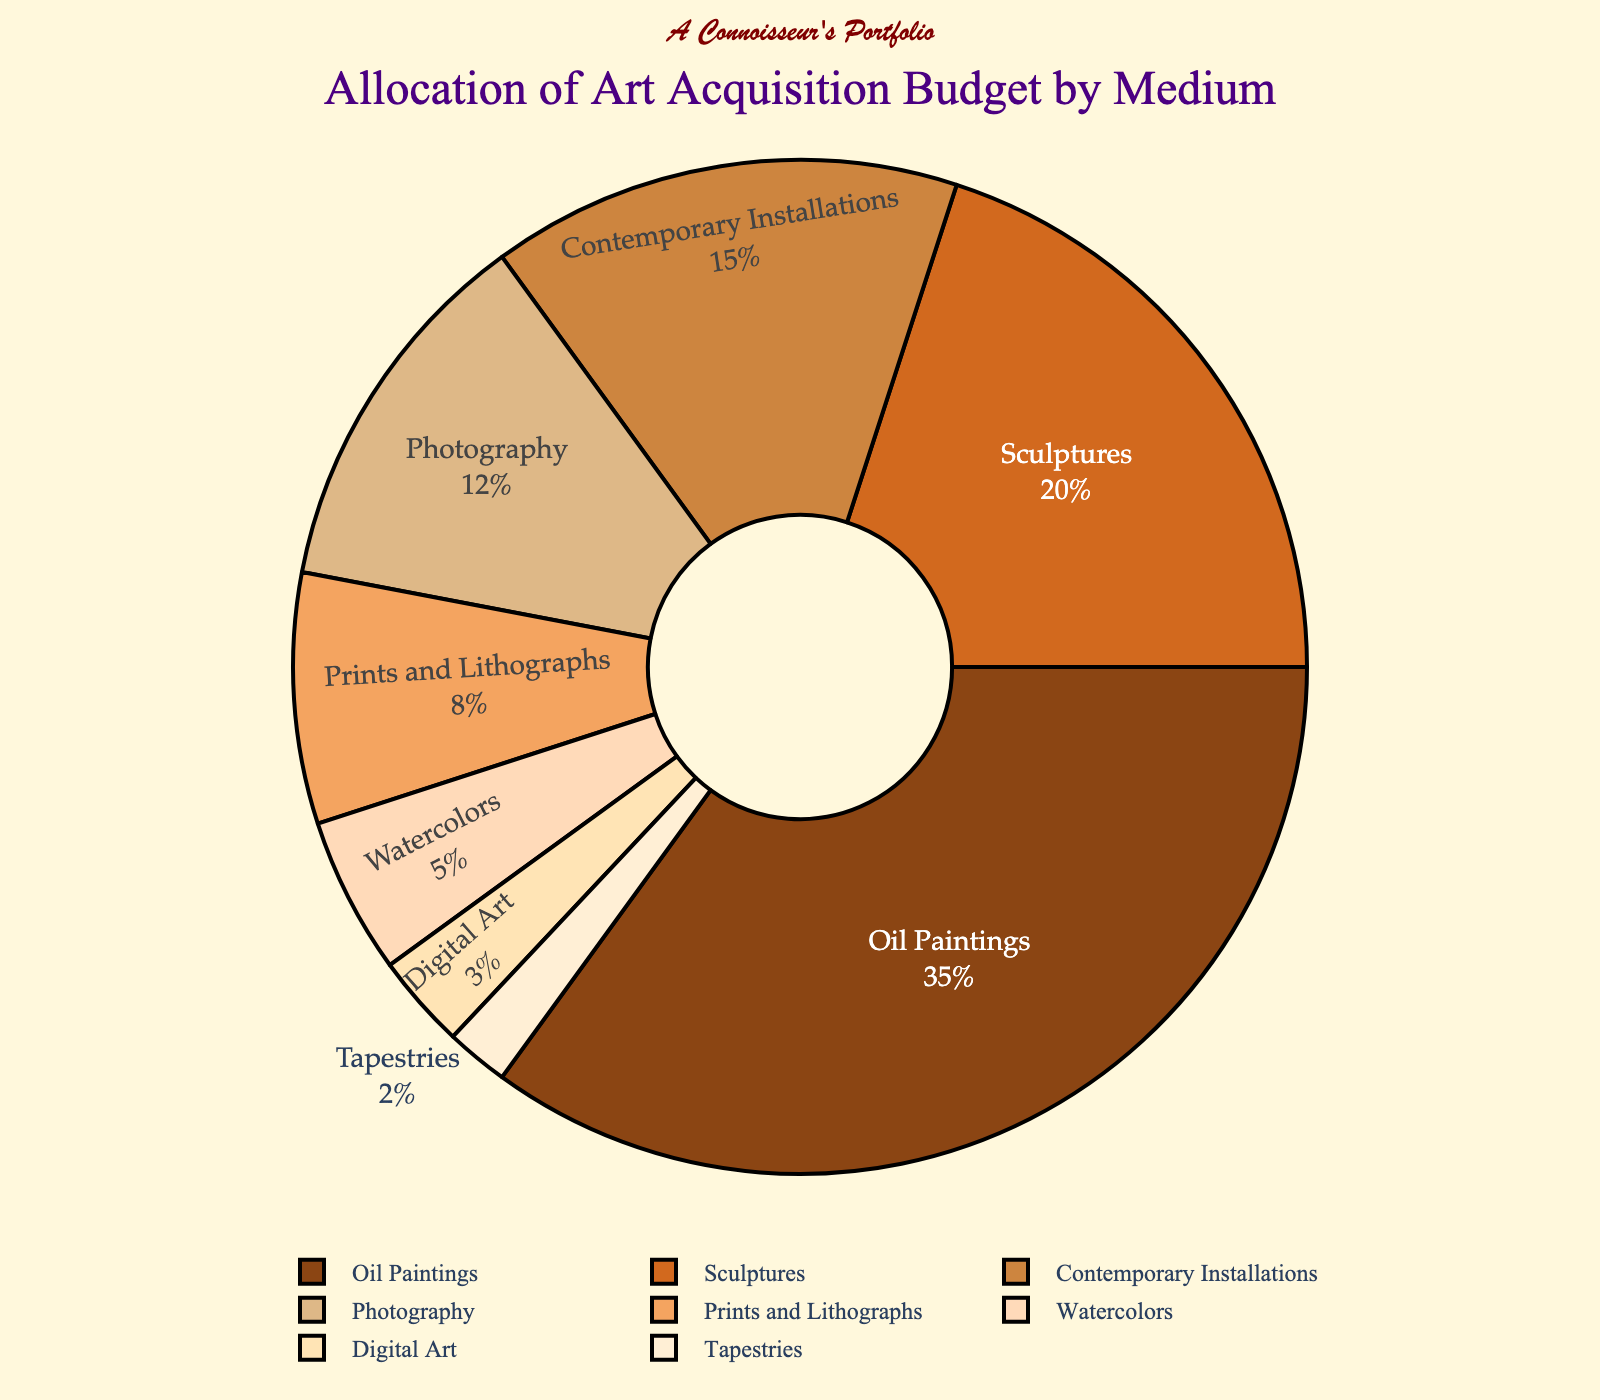What medium receives the largest portion of the art acquisition budget? The pie chart shows that Oil Paintings receive the largest portion of the art acquisition budget with 35%. This is visible as the largest sector.
Answer: Oil Paintings How much more percentage is allocated to Oil Paintings compared to Digital Art? Oil Paintings are allocated 35%, while Digital Art is allocated 3%. The difference is calculated as 35% - 3%.
Answer: 32% What is the total percentage allocated to Photography, Prints and Lithographs, and Watercolors combined? Photography has 12%, Prints and Lithographs have 8%, and Watercolors have 5%. Adding these together: 12% + 8% + 5% = 25%.
Answer: 25% What is the difference between the allocation for Sculptures and the allocation for Prints and Lithographs? Sculptures are allocated 20%, and Prints and Lithographs are allocated 8%. The difference is calculated as 20% - 8%.
Answer: 12% How does the allocation for Digital Art visually compare in size to the allocation for Tapestries in the pie chart? Visually, the portion of the pie chart for Digital Art (3%) is slightly larger than that for Tapestries (2%) due to the percentage difference.
Answer: Slightly larger Which two mediums receive the smallest allocations, and what is their combined percentage? According to the visible slices of the pie chart, the smallest allocations are for Tapestries (2%) and Digital Art (3%). Adding these gives 2% + 3% = 5%.
Answer: Tapestries and Digital Art, 5% If the gallery decided to double the budget allocation for Watercolors, what would the new allocation percentage be? Currently, Watercolors have 5%. Doubling this allocation would be 2 * 5% = 10%.
Answer: 10% How much higher in percentage is the budget for Photography compared to Digital Art? Photography is allocated 12%, and Digital Art is allocated 3%. The difference is calculated as 12% - 3%.
Answer: 9% 